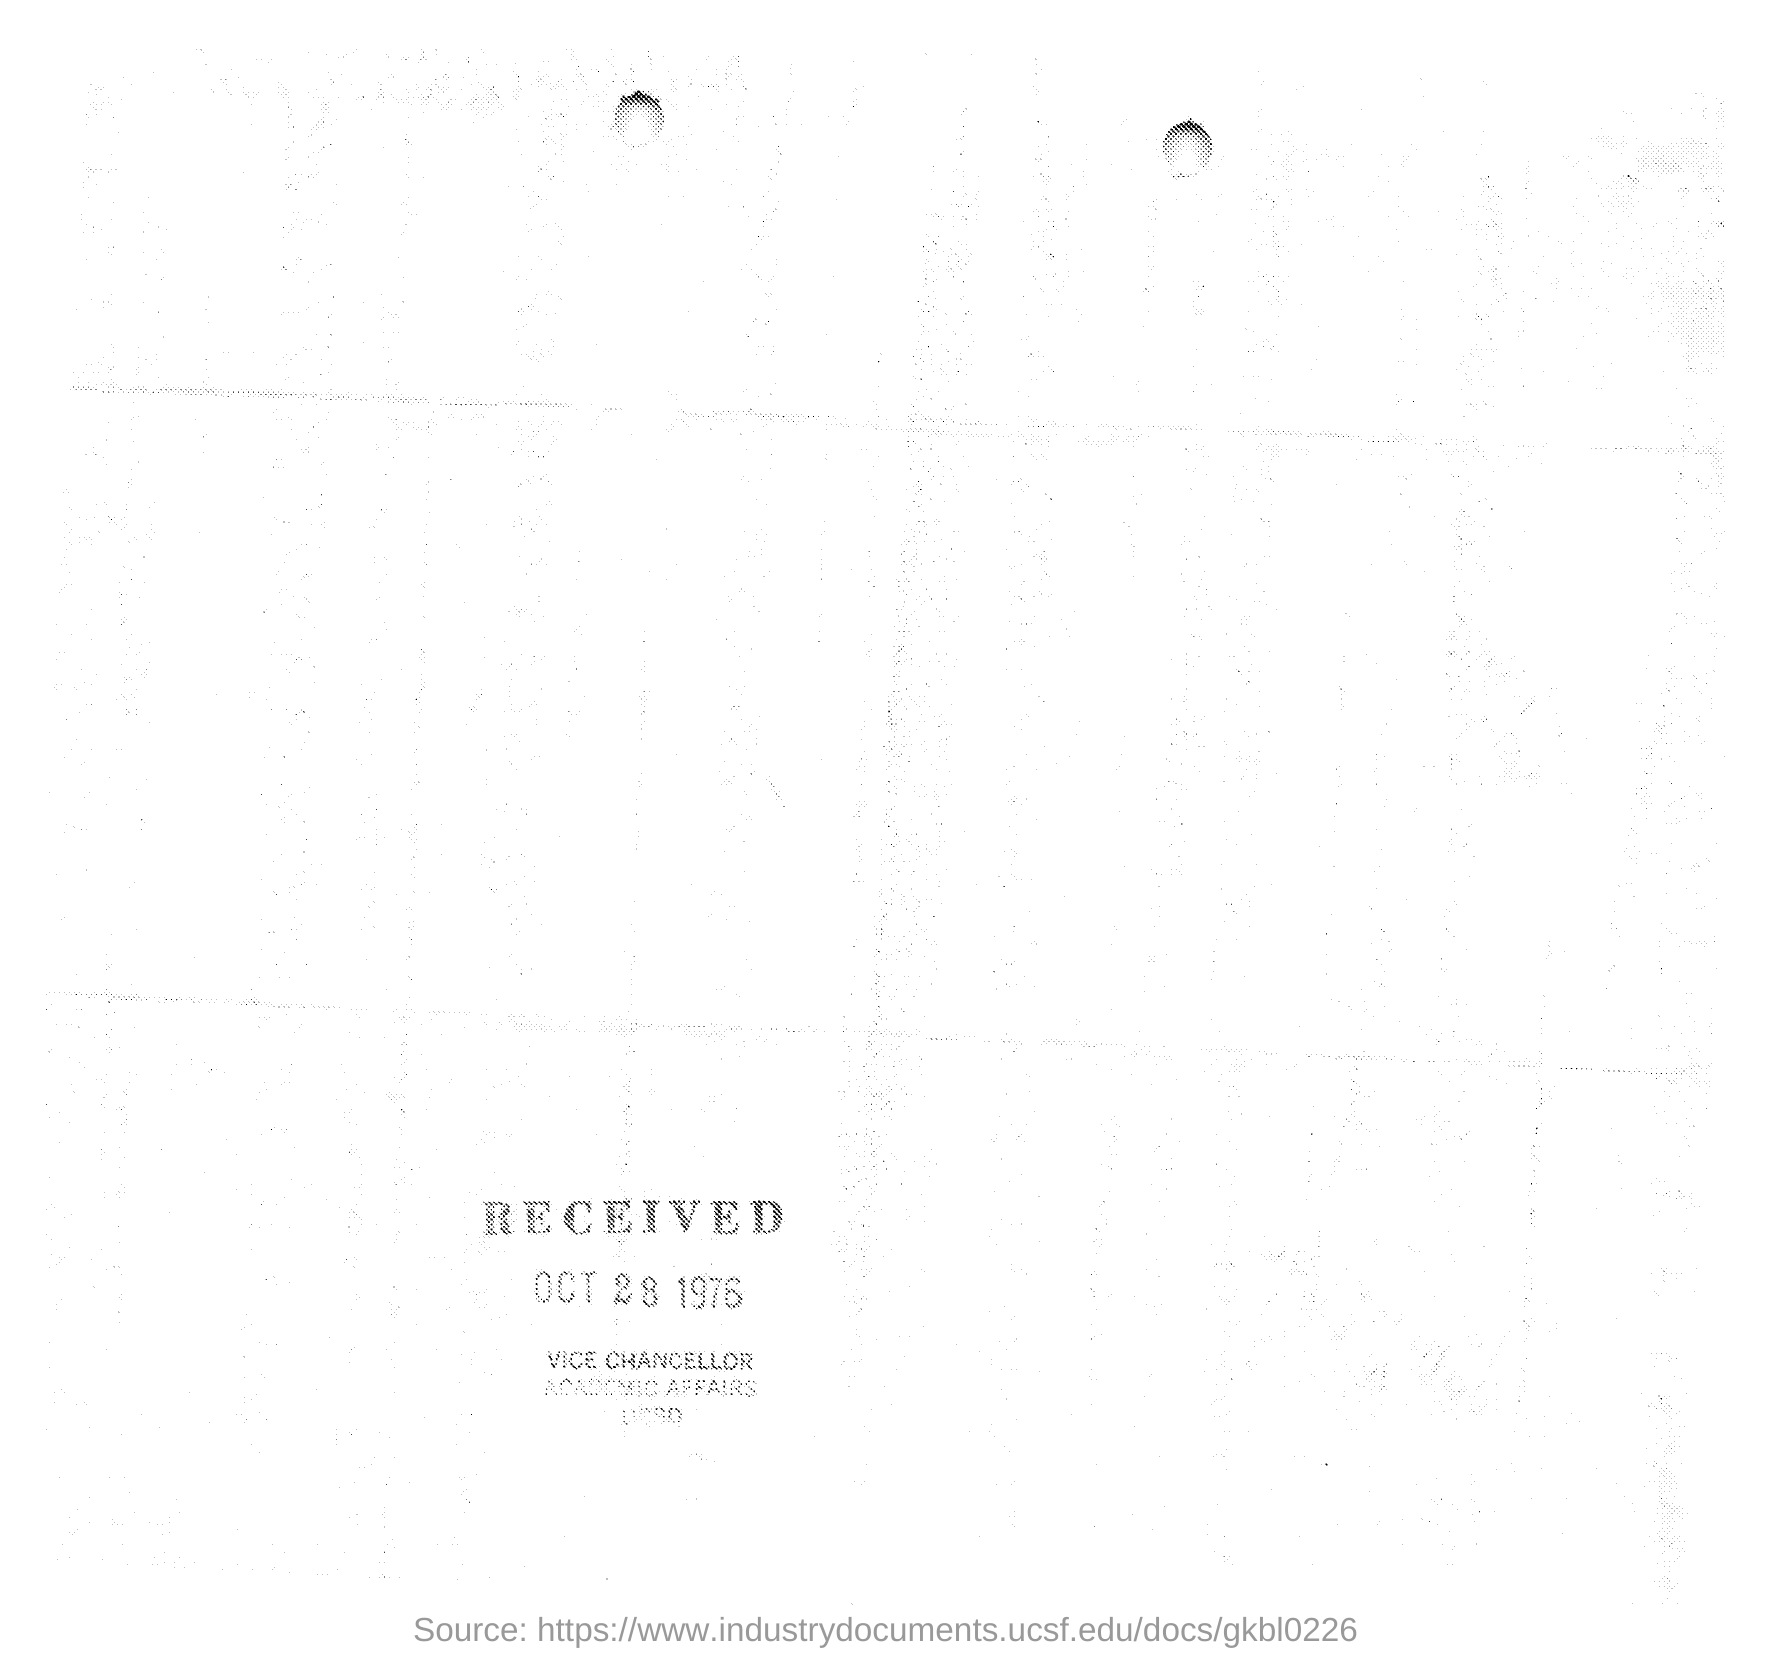When is the document recived?
Provide a short and direct response. OCT 28 1976. 